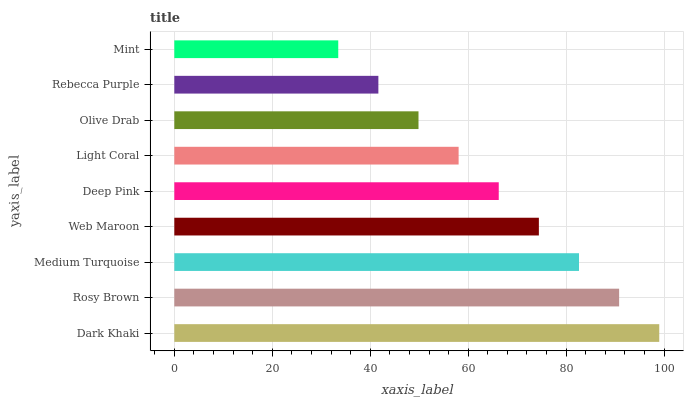Is Mint the minimum?
Answer yes or no. Yes. Is Dark Khaki the maximum?
Answer yes or no. Yes. Is Rosy Brown the minimum?
Answer yes or no. No. Is Rosy Brown the maximum?
Answer yes or no. No. Is Dark Khaki greater than Rosy Brown?
Answer yes or no. Yes. Is Rosy Brown less than Dark Khaki?
Answer yes or no. Yes. Is Rosy Brown greater than Dark Khaki?
Answer yes or no. No. Is Dark Khaki less than Rosy Brown?
Answer yes or no. No. Is Deep Pink the high median?
Answer yes or no. Yes. Is Deep Pink the low median?
Answer yes or no. Yes. Is Light Coral the high median?
Answer yes or no. No. Is Light Coral the low median?
Answer yes or no. No. 